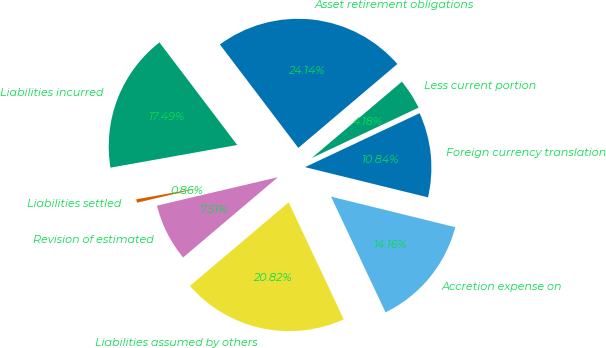Convert chart. <chart><loc_0><loc_0><loc_500><loc_500><pie_chart><fcel>Asset retirement obligations<fcel>Liabilities incurred<fcel>Liabilities settled<fcel>Revision of estimated<fcel>Liabilities assumed by others<fcel>Accretion expense on<fcel>Foreign currency translation<fcel>Less current portion<nl><fcel>24.14%<fcel>17.49%<fcel>0.86%<fcel>7.51%<fcel>20.82%<fcel>14.16%<fcel>10.84%<fcel>4.18%<nl></chart> 